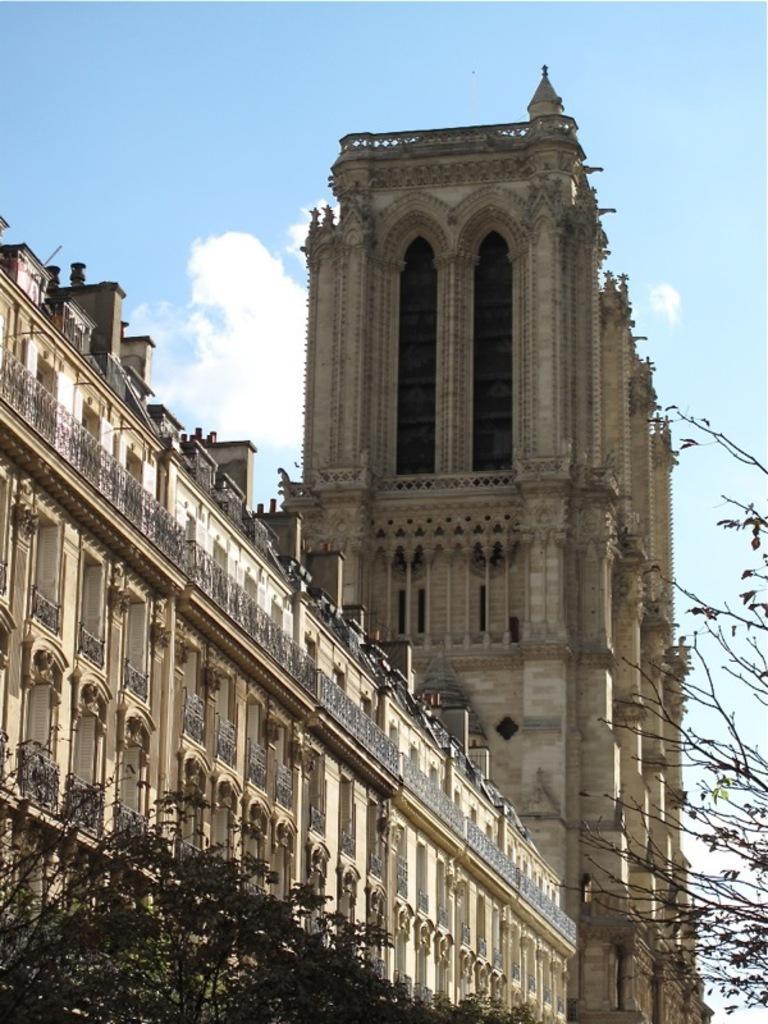Could you give a brief overview of what you see in this image? In this picture we can see trees, a building and the sky. 